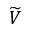<formula> <loc_0><loc_0><loc_500><loc_500>\widetilde { V }</formula> 